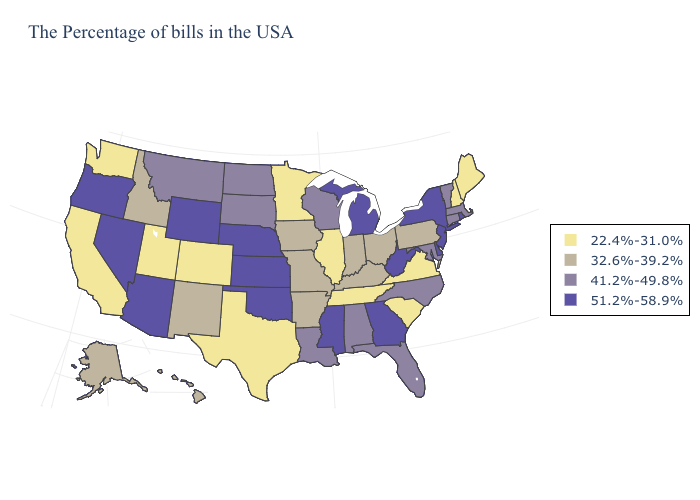Name the states that have a value in the range 32.6%-39.2%?
Keep it brief. Pennsylvania, Ohio, Kentucky, Indiana, Missouri, Arkansas, Iowa, New Mexico, Idaho, Alaska, Hawaii. What is the value of Iowa?
Write a very short answer. 32.6%-39.2%. What is the value of Minnesota?
Short answer required. 22.4%-31.0%. Name the states that have a value in the range 51.2%-58.9%?
Write a very short answer. Rhode Island, New York, New Jersey, Delaware, West Virginia, Georgia, Michigan, Mississippi, Kansas, Nebraska, Oklahoma, Wyoming, Arizona, Nevada, Oregon. Does Maryland have the same value as Utah?
Quick response, please. No. Among the states that border Arkansas , does Missouri have the highest value?
Keep it brief. No. What is the lowest value in states that border West Virginia?
Concise answer only. 22.4%-31.0%. What is the value of Arkansas?
Answer briefly. 32.6%-39.2%. Which states have the highest value in the USA?
Be succinct. Rhode Island, New York, New Jersey, Delaware, West Virginia, Georgia, Michigan, Mississippi, Kansas, Nebraska, Oklahoma, Wyoming, Arizona, Nevada, Oregon. Name the states that have a value in the range 22.4%-31.0%?
Quick response, please. Maine, New Hampshire, Virginia, South Carolina, Tennessee, Illinois, Minnesota, Texas, Colorado, Utah, California, Washington. Name the states that have a value in the range 32.6%-39.2%?
Concise answer only. Pennsylvania, Ohio, Kentucky, Indiana, Missouri, Arkansas, Iowa, New Mexico, Idaho, Alaska, Hawaii. Does Alaska have a lower value than Washington?
Quick response, please. No. Does the first symbol in the legend represent the smallest category?
Be succinct. Yes. What is the value of North Dakota?
Answer briefly. 41.2%-49.8%. Does Nevada have the lowest value in the USA?
Short answer required. No. 